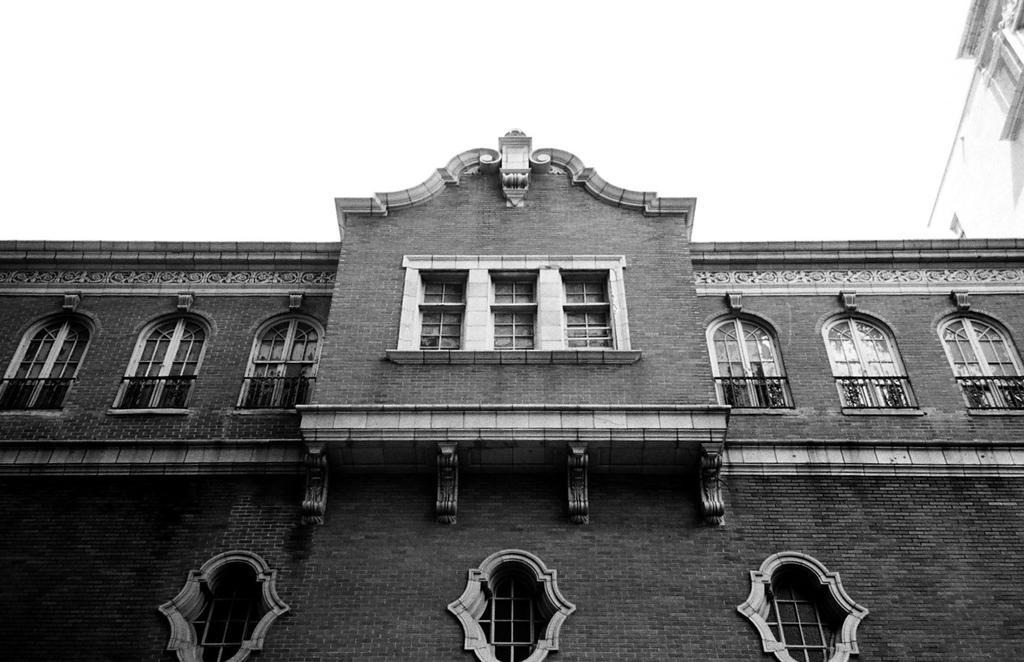Please provide a concise description of this image. In this image there is a building with windows, beside it there is a white color building. 